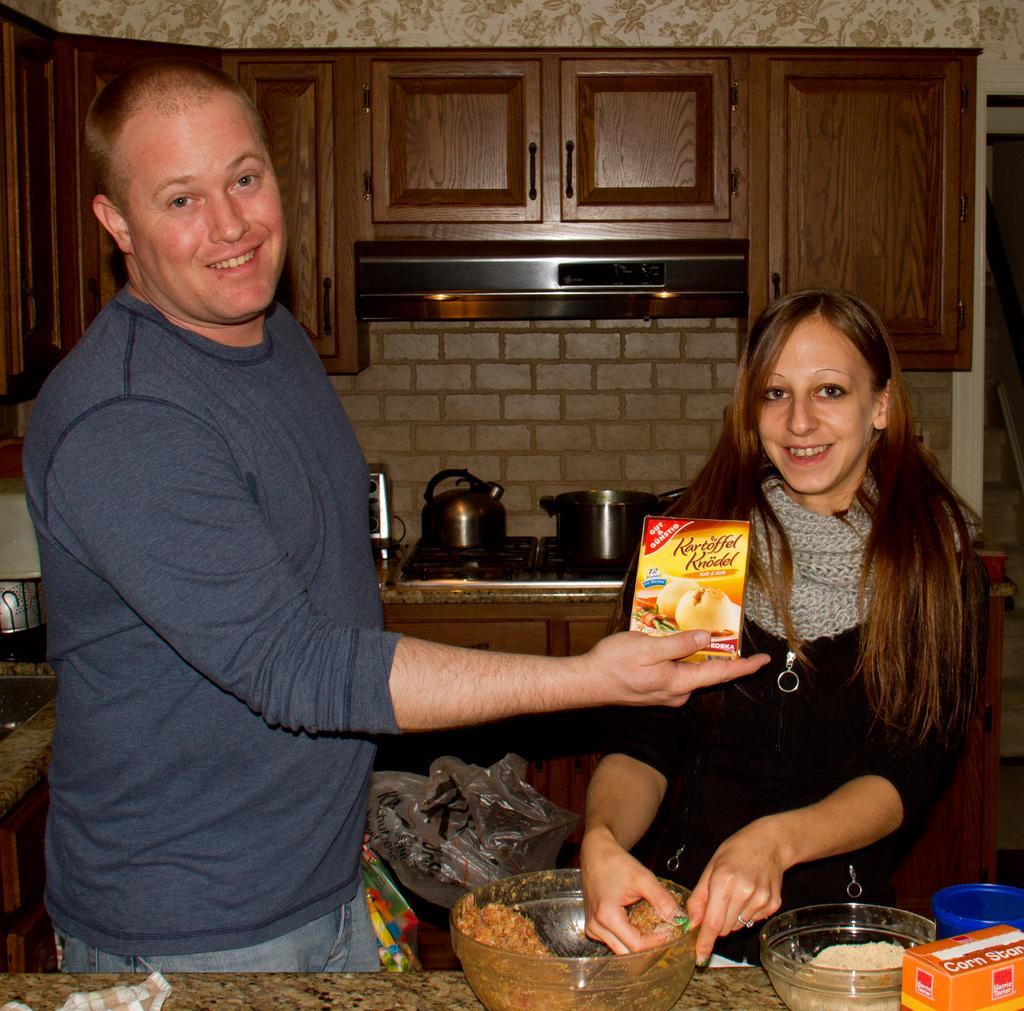In one or two sentences, can you explain what this image depicts? In this picture I can see a man and a woman standing in front and I see that, the man is holding a box and I see something is written on it. I can also see that both of them are smiling and the woman is holding brown color food. On the bottom of this picture I can see the counter top, on which there are bowls and another box. In the background I can see the drawers, few utensils and the wall. 